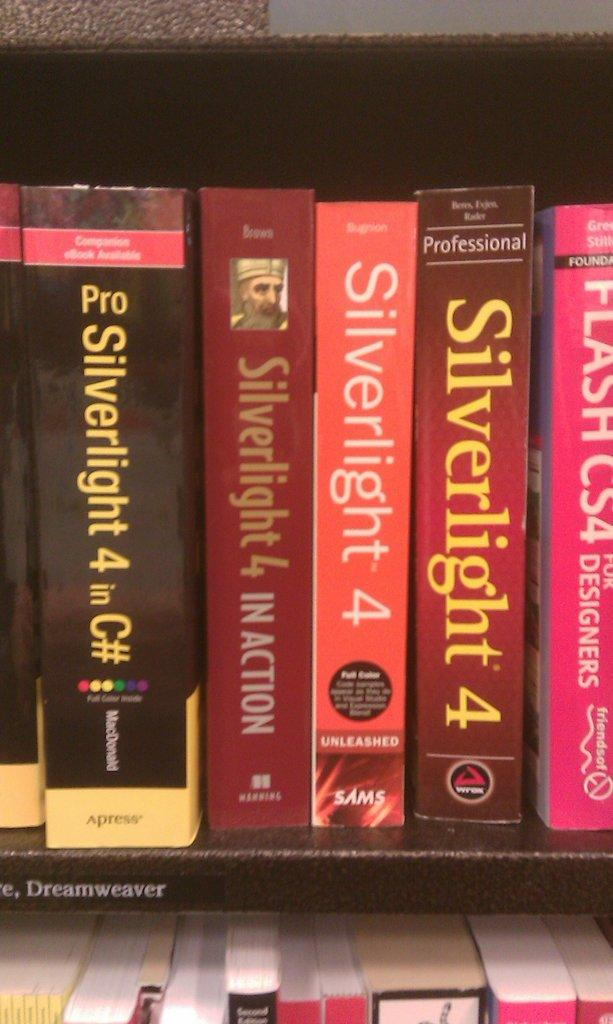<image>
Render a clear and concise summary of the photo. Row of Silverlight 4 books in a line on a shelf. 